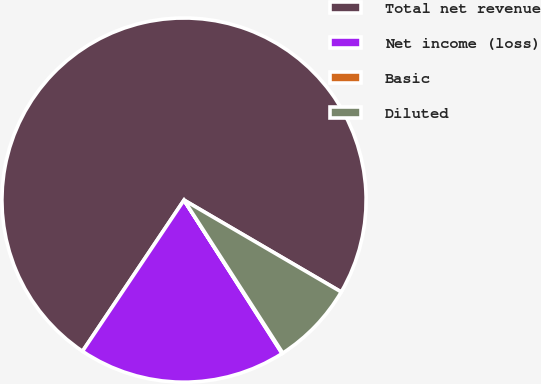<chart> <loc_0><loc_0><loc_500><loc_500><pie_chart><fcel>Total net revenue<fcel>Net income (loss)<fcel>Basic<fcel>Diluted<nl><fcel>74.01%<fcel>18.47%<fcel>0.07%<fcel>7.46%<nl></chart> 